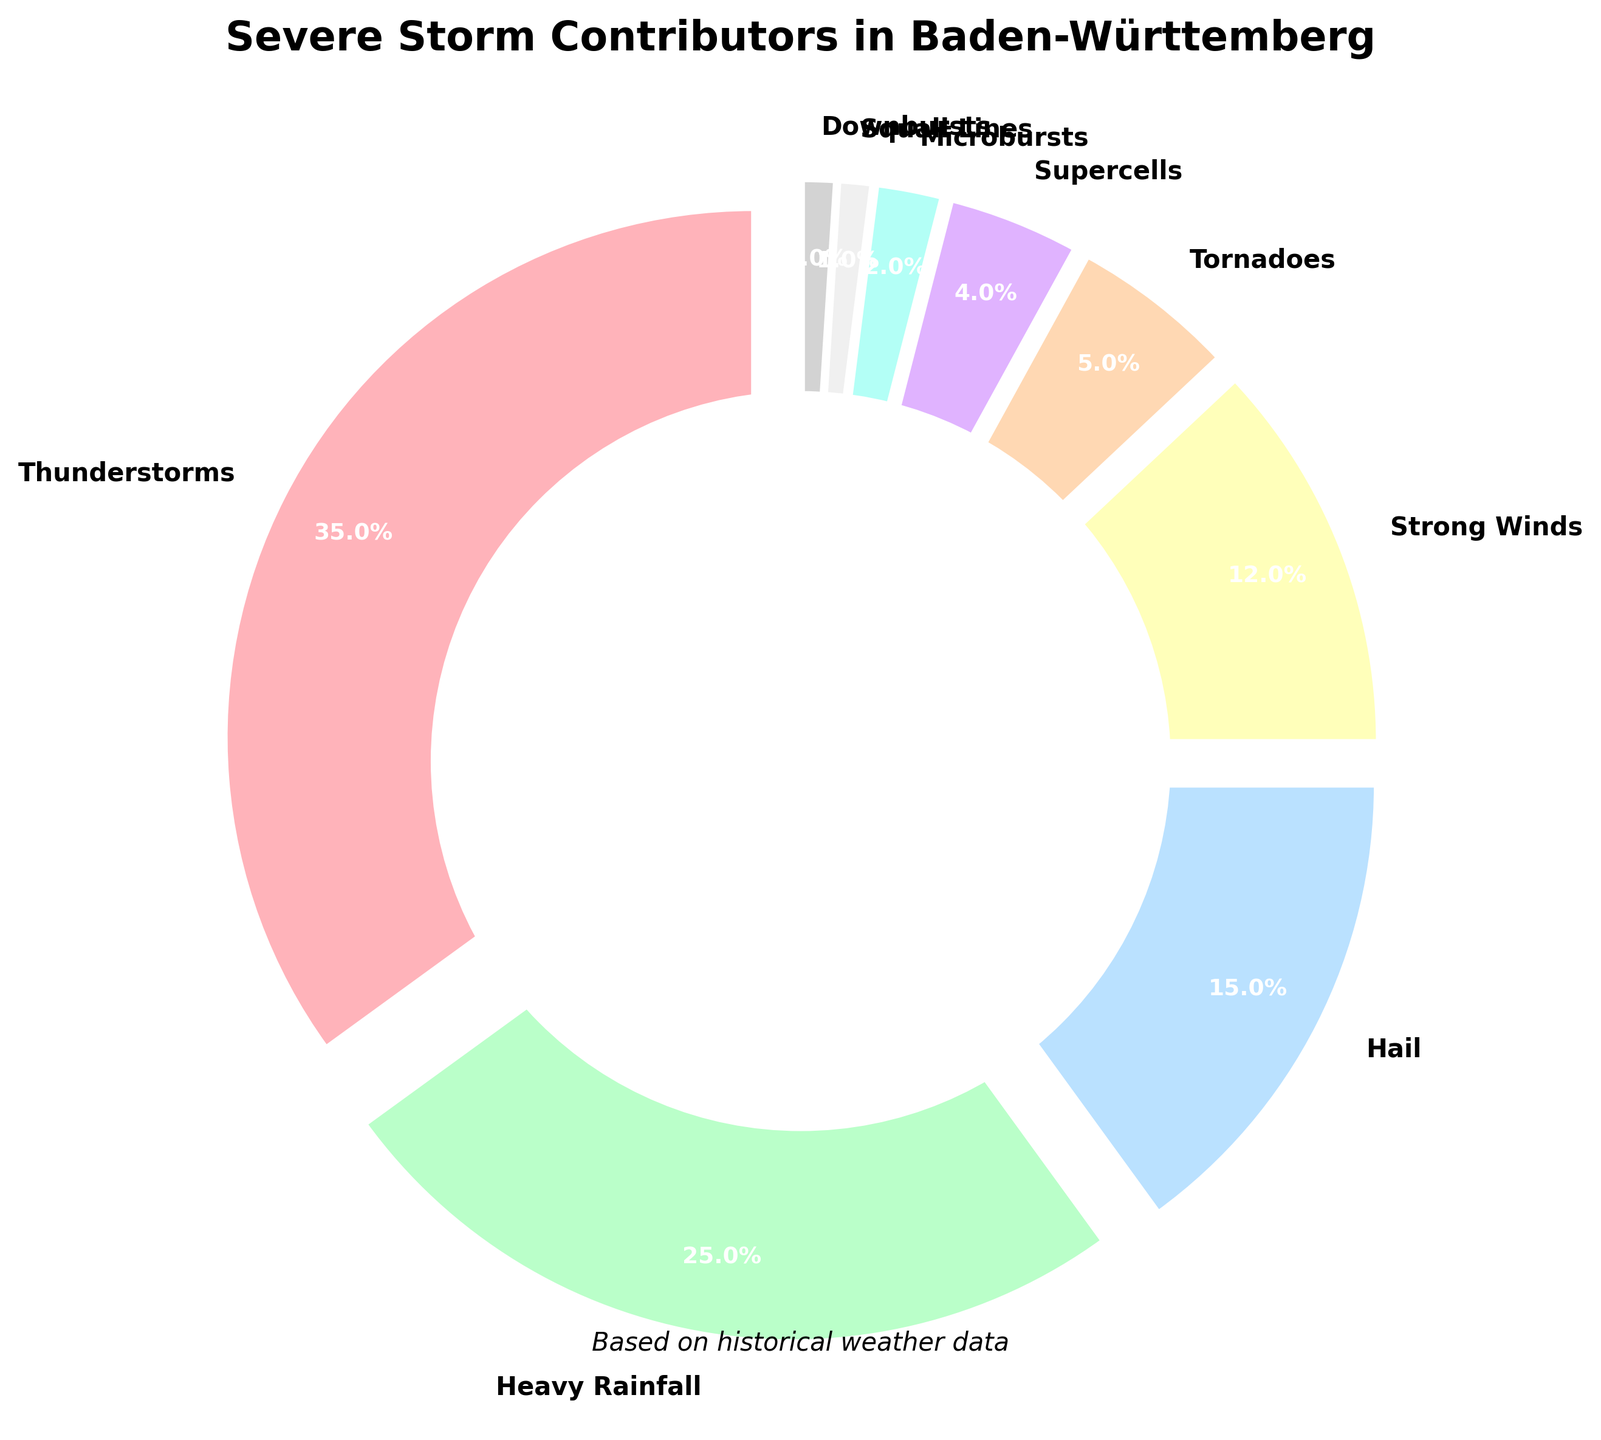What percentage of severe storms does Heavy Rainfall contribute to? The pie chart shows the percentage contribution of different weather phenomena. By looking at the slice labeled "Heavy Rainfall," we see it constitutes 25%.
Answer: 25% Which weather phenomenon has the smallest contribution to severe storms? The chart shows contributions of different weather phenomena. The smallest slices, labeled "Squall Lines" and "Downbursts," each constitute 1%.
Answer: Squall Lines and Downbursts What is the difference in percentage between Thunderstorms and Tornadoes? Thunderstorms contribute 35% and Tornadoes contribute 5%. Subtracting Tornadoes' contribution from Thunderstorms' (35% - 5%) gives the difference.
Answer: 30% How much more does Hail contribute to severe storms compared to Microbursts? The contribution of Hail is 15% and Microbursts is 2%. The difference (15% - 2%) shows that Hail contributes 13% more.
Answer: 13% What are the three largest contributors to severe storms? The pie chart shows the contributions. The largest slices correspond to Thunderstorms (35%), Heavy Rainfall (25%), and Hail (15%).
Answer: Thunderstorms, Heavy Rainfall, and Hail Which weather phenomena together contribute exactly half of the severe storms? Thunderstorms contribute 35% and Heavy Rainfall contributes 25%. Adding them together (35% + 25%) equals 60%.
Answer: Thunderstorms and Heavy Rainfall Are there more slices contributing below 5% or above 5%? Identify slices 5% and below: Tornadoes (5%), Supercells (4%), Microbursts (2%), Squall Lines (1%), and Downbursts (1%). These total 5 unique slices. Slices above 5% include Thunderstorms (35%), Heavy Rainfall (25%), Hail (15%), and Strong Winds (12%), totaling 4 slices.
Answer: Below 5% Combine the contributions of Tornadoes and Supercells. What is the new percentage? The contribution of Tornadoes is 5% and Supercells is 4%. Adding these (5% + 4%) gives the combined percentage.
Answer: 9% Which weather phenomenon contributing more than 10% has the smallest share? From the pie chart, the phenomena contributing more than 10% are Thunderstorms (35%), Heavy Rainfall (25%), Hail (15%), and Strong Winds (12%). The smallest share among these is Strong Winds with 12%.
Answer: Strong Winds What's the average percentage contribution for all phenomena listed? Sum all percentages: 35% + 25% + 15% + 12% + 5% + 4% + 2% + 1% + 1% = 100%. There are 9 phenomena, so the average is 100% / 9 = ~11.11%.
Answer: ~11.11% 